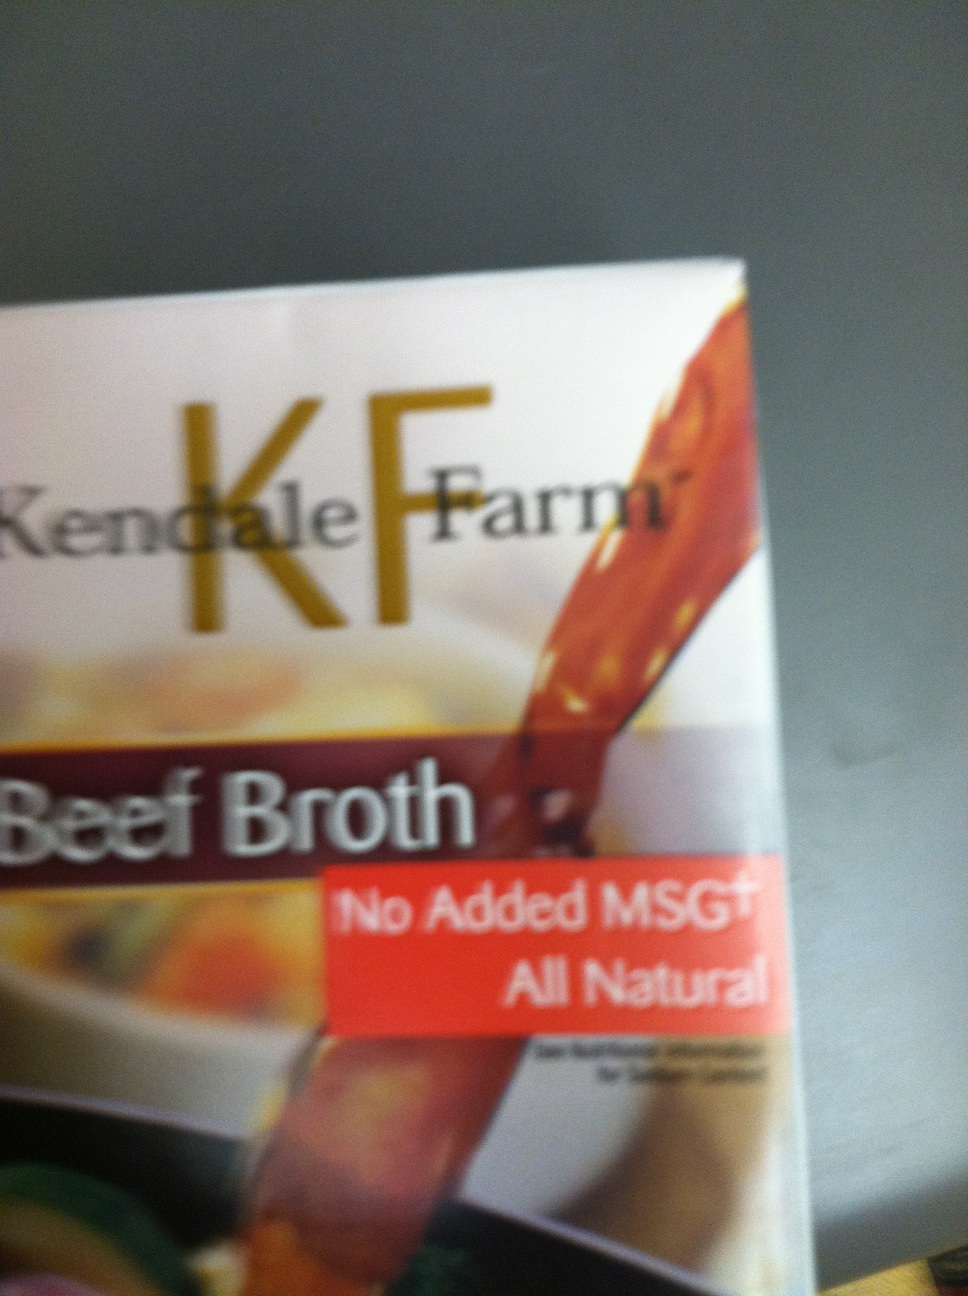What is this? This is a package of Kendale Farm Beef Broth. The label indicates that it is an all-natural product with no added MSG, which is often used to enhance flavor. 